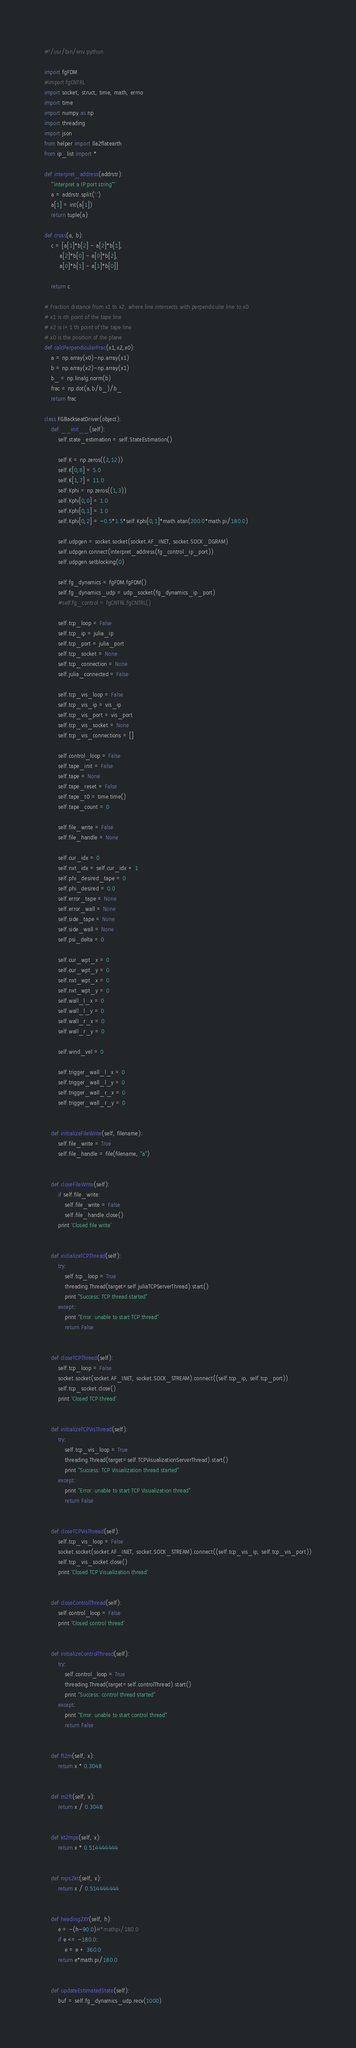<code> <loc_0><loc_0><loc_500><loc_500><_Python_>#!/usr/bin/env python

import fgFDM
#import fgCNTRL
import socket, struct, time, math, errno
import time
import numpy as np
import threading
import json
from helper import lla2flatearth
from ip_list import *

def interpret_address(addrstr):
    '''interpret a IP:port string'''
    a = addrstr.split(':')
    a[1] = int(a[1])
    return tuple(a)

def cross(a, b):
    c = [a[1]*b[2] - a[2]*b[1],
         a[2]*b[0] - a[0]*b[2],
         a[0]*b[1] - a[1]*b[0]]

    return c

# Fraction distance from x1 to x2, where line intersects with perpendicular line to x0
# x1 is ith point of the tape line
# x2 is i+1 th point of the tape line
# x0 is the position of the plane
def calcPerpendicularFrac(x1,x2,x0):
	a = np.array(x0)-np.array(x1)
	b = np.array(x2)-np.array(x1)
	b_ = np.linalg.norm(b)
	frac = np.dot(a,b/b_)/b_
	return frac

class FGBackseatDriver(object):
	def __init__(self):
		self.state_estimation = self.StateEstimation()

		self.K = np.zeros((2,12))
		self.K[0,6] = 5.0
		self.K[1,7] = 11.0
		self.Kphi = np.zeros((1,3))
		self.Kphi[0,0] = 1.0
		self.Kphi[0,1] = 1.0
		self.Kphi[0,2] = -0.5*1.5*self.Kphi[0,1]*math.atan(200.0*math.pi/180.0)

		self.udpgen = socket.socket(socket.AF_INET, socket.SOCK_DGRAM)
		self.udpgen.connect(interpret_address(fg_control_ip_port))
		self.udpgen.setblocking(0)

		self.fg_dynamics = fgFDM.fgFDM()
		self.fg_dynamics_udp = udp_socket(fg_dynamics_ip_port)
		#self.fg_control = fgCNTRL.fgCNTRL()

		self.tcp_loop = False
		self.tcp_ip = julia_ip
		self.tcp_port = julia_port
		self.tcp_socket = None
		self.tcp_connection = None
		self.julia_connected = False

		self.tcp_vis_loop = False
		self.tcp_vis_ip = vis_ip
		self.tcp_vis_port = vis_port
		self.tcp_vis_socket = None
		self.tcp_vis_connections = []

		self.control_loop = False
		self.tape_init = False
		self.tape = None
		self.tape_reset = False
		self.tape_t0 = time.time()
		self.tape_count = 0
		
		self.file_write = False
		self.file_handle = None
		
		self.cur_idx = 0
		self.nxt_idx = self.cur_idx + 1
		self.phi_desired_tape = 0
		self.phi_desired = 0.0
		self.error_tape = None
		self.error_wall = None
		self.side_tape = None
		self.side_wall = None
		self.psi_delta = 0

		self.cur_wpt_x = 0
		self.cur_wpt_y = 0
		self.nxt_wpt_x = 0
		self.nxt_wpt_y = 0
		self.wall_l_x = 0
		self.wall_l_y = 0
		self.wall_r_x = 0
		self.wall_r_y = 0
		
		self.wind_vel = 0

		self.trigger_wall_l_x = 0
		self.trigger_wall_l_y = 0
		self.trigger_wall_r_x = 0
		self.trigger_wall_r_y = 0
	
	
	def initializeFileWrite(self, filename):
		self.file_write = True
		self.file_handle = file(filename, "a")
		
		
	def closeFileWrite(self):
		if self.file_write:
			self.file_write = False
			self.file_handle.close()
		print 'Closed file write'


	def initializeTCPThread(self):
		try:
			self.tcp_loop = True
			threading.Thread(target=self.juliaTCPServerThread).start()
			print "Success: TCP thread started"
		except:
			print "Error: unable to start TCP thread"
			return False


	def closeTCPThread(self):
		self.tcp_loop = False
		socket.socket(socket.AF_INET, socket.SOCK_STREAM).connect((self.tcp_ip, self.tcp_port))
		self.tcp_socket.close()	
		print 'Closed TCP thread'


	def initializeTCPVisThread(self):
		try:
			self.tcp_vis_loop = True
			threading.Thread(target=self.TCPVisualizationServerThread).start()
			print "Success: TCP Visualization thread started"
		except:
			print "Error: unable to start TCP Visualization thread"
			return False


	def closeTCPVisThread(self):
		self.tcp_vis_loop = False
		socket.socket(socket.AF_INET, socket.SOCK_STREAM).connect((self.tcp_vis_ip, self.tcp_vis_port))
		self.tcp_vis_socket.close()
		print 'Closed TCP Visualization thread'


	def closeControlThread(self):
		self.control_loop = False
		print 'Closed control thread'


	def initializeControlThread(self):
		try:
			self.control_loop = True
			threading.Thread(target=self.controlThread).start()
			print "Success: control thread started"
		except:
			print "Error: unable to start control thread"
			return False


	def ft2m(self, x):
		return x * 0.3048


	def m2ft(self, x):
		return x / 0.3048


	def kt2mps(self, x):
		return x * 0.514444444


	def mps2kt(self, x):
		return x / 0.514444444
		
	
	def heading2XY(self, h):
		e = -(h-90.0)#*mathpi/180.0
		if e <= -180.0:
			e = e + 360.0
		return e*math.pi/180.0


	def updateEstimatedState(self):
		buf = self.fg_dynamics_udp.recv(1000)</code> 